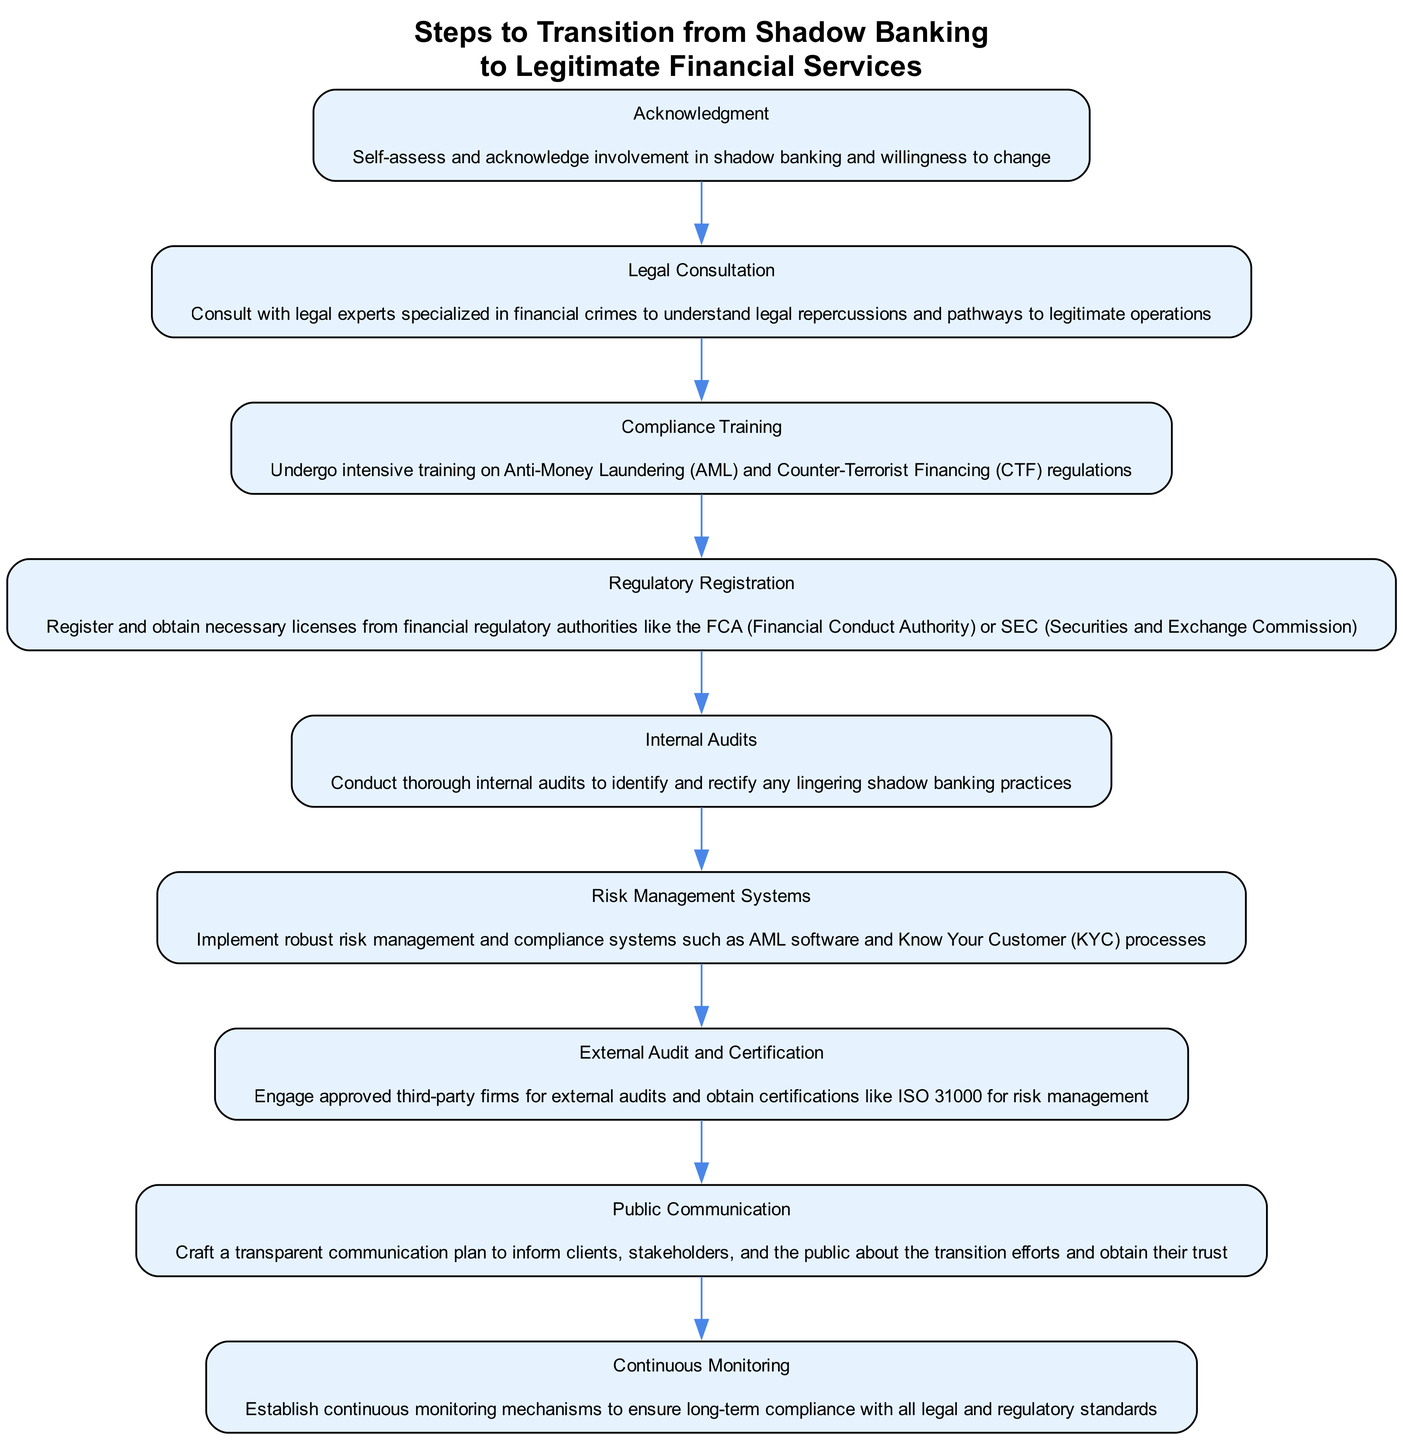What is the first step in the transition process? The first step in the diagram is labeled "Acknowledgment," which involves self-assessing and acknowledging involvement in shadow banking.
Answer: Acknowledgment How many steps are in the transition process? By observing the diagram, there are a total of 9 steps listed in the flow chart for the transition process.
Answer: 9 What follows after "Legal Consultation"? The flow of the diagram indicates that "Compliance Training" directly follows the "Legal Consultation" step.
Answer: Compliance Training Which step requires engaging third-party firms? The step that requires engaging third-party firms is "External Audit and Certification," where third-party firms are involved for external audits.
Answer: External Audit and Certification What is the final step in the transition process? The final step, as indicated at the bottom of the flow chart, is "Continuous Monitoring," which involves establishing mechanisms for long-term compliance.
Answer: Continuous Monitoring Which step emphasizes transparency to clients and stakeholders? The step focused on transparency to clients and stakeholders is "Public Communication," where a transparent communication plan is crafted.
Answer: Public Communication What is a key action in "Internal Audits"? A key action in "Internal Audits" is to conduct thorough audits to identify and rectify any lingering shadow banking practices.
Answer: Identify and rectify lingering practices What systems are to be implemented according to a specific step? The step "Risk Management Systems" specifies the implementation of robust risk management and compliance systems like AML software and KYC processes.
Answer: AML software and KYC processes What is the relationship between "Regulatory Registration" and "Internal Audits"? In the flow chart, "Regulatory Registration" precedes "Internal Audits," indicating that registration with regulatory authorities occurs before conducting internal audits.
Answer: "Regulatory Registration" precedes "Internal Audits" 